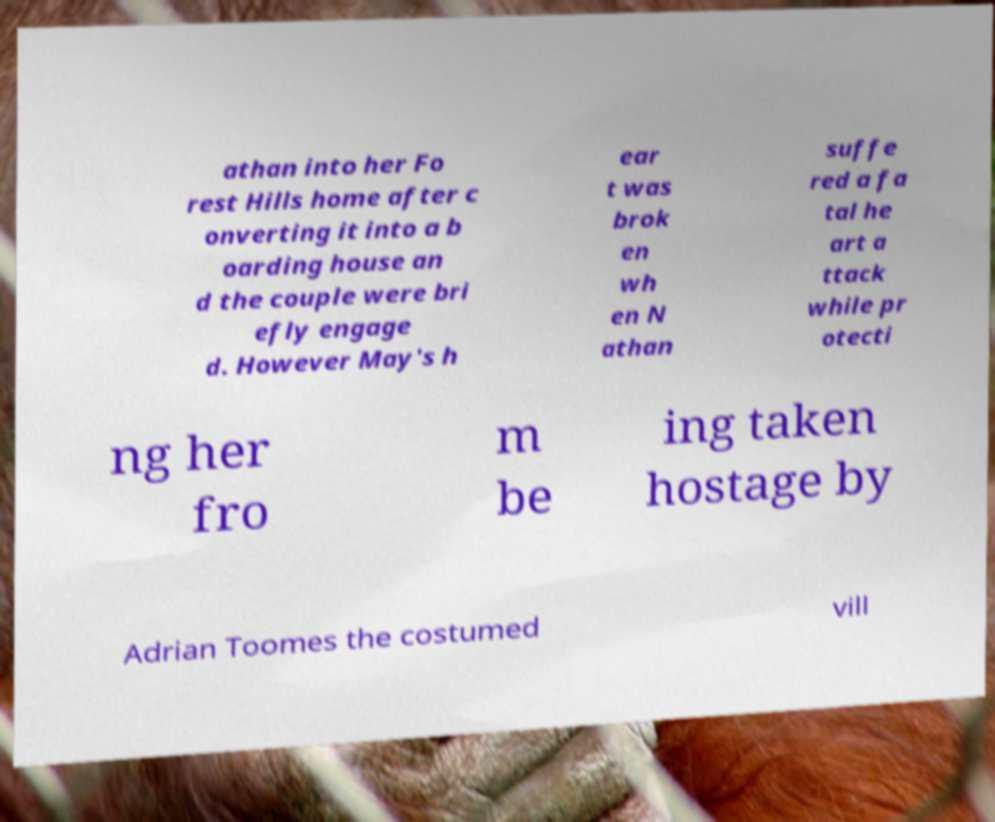Could you assist in decoding the text presented in this image and type it out clearly? athan into her Fo rest Hills home after c onverting it into a b oarding house an d the couple were bri efly engage d. However May's h ear t was brok en wh en N athan suffe red a fa tal he art a ttack while pr otecti ng her fro m be ing taken hostage by Adrian Toomes the costumed vill 